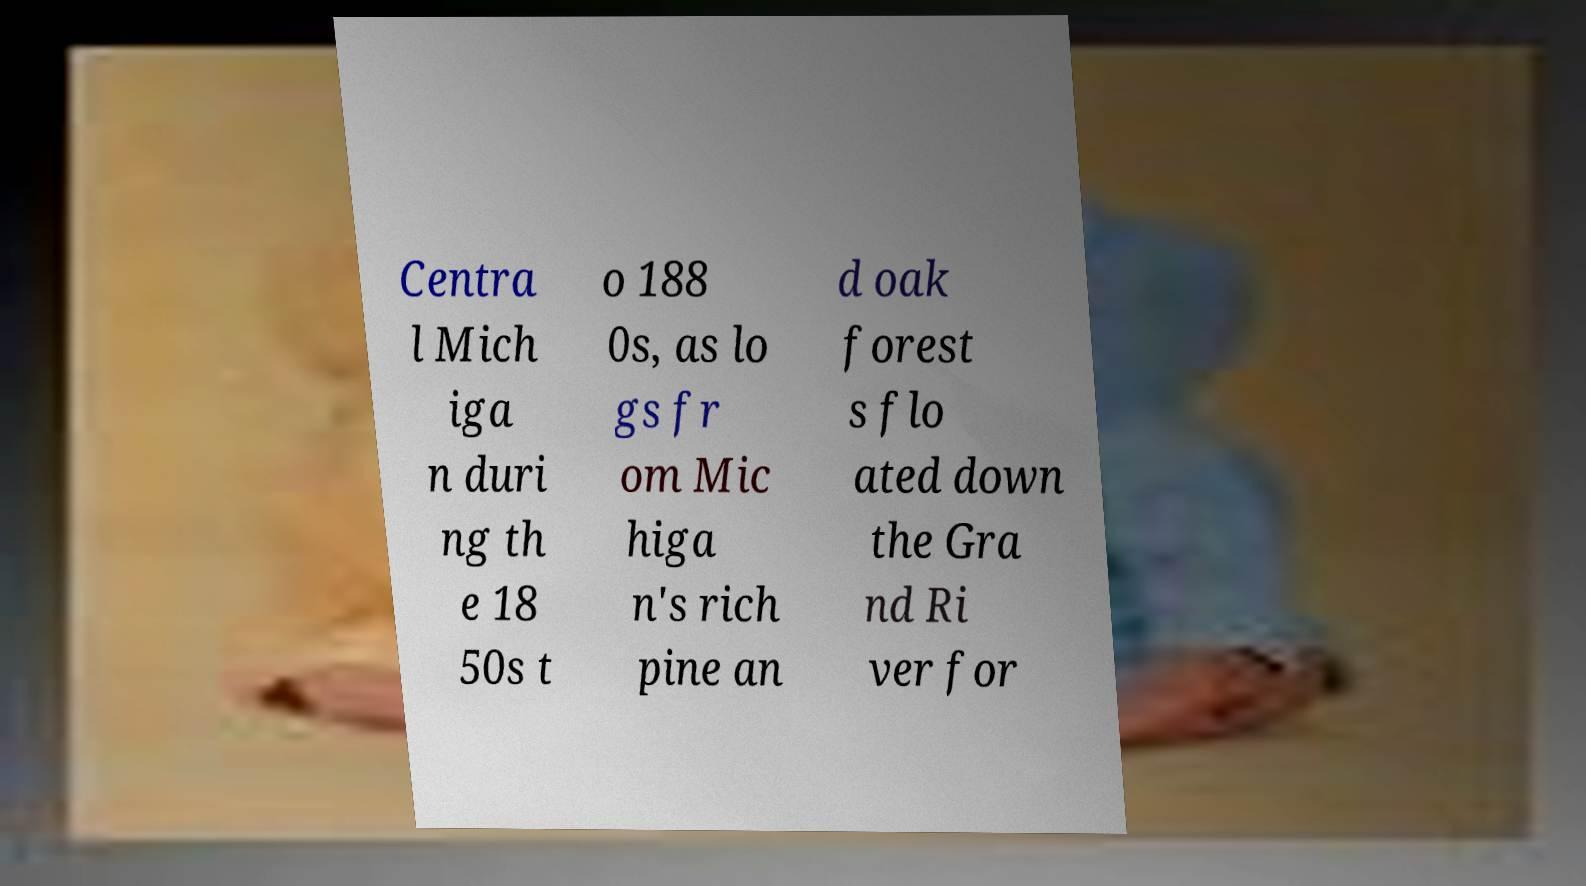I need the written content from this picture converted into text. Can you do that? Centra l Mich iga n duri ng th e 18 50s t o 188 0s, as lo gs fr om Mic higa n's rich pine an d oak forest s flo ated down the Gra nd Ri ver for 